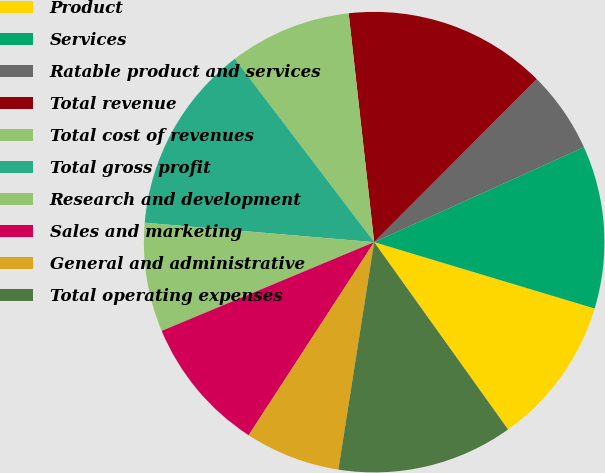Convert chart to OTSL. <chart><loc_0><loc_0><loc_500><loc_500><pie_chart><fcel>Product<fcel>Services<fcel>Ratable product and services<fcel>Total revenue<fcel>Total cost of revenues<fcel>Total gross profit<fcel>Research and development<fcel>Sales and marketing<fcel>General and administrative<fcel>Total operating expenses<nl><fcel>10.47%<fcel>11.42%<fcel>5.75%<fcel>14.25%<fcel>8.58%<fcel>13.31%<fcel>7.64%<fcel>9.53%<fcel>6.69%<fcel>12.36%<nl></chart> 